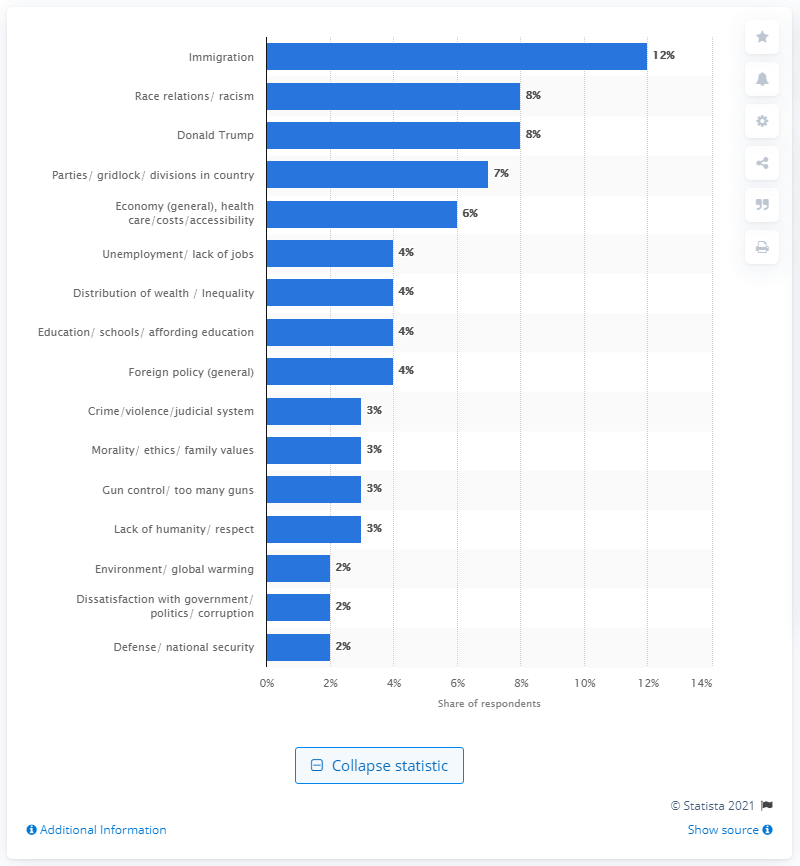Point out several critical features in this image. According to the responses of 8% of respondents, Donald Trump is viewed as the most significant problem facing the United States today 